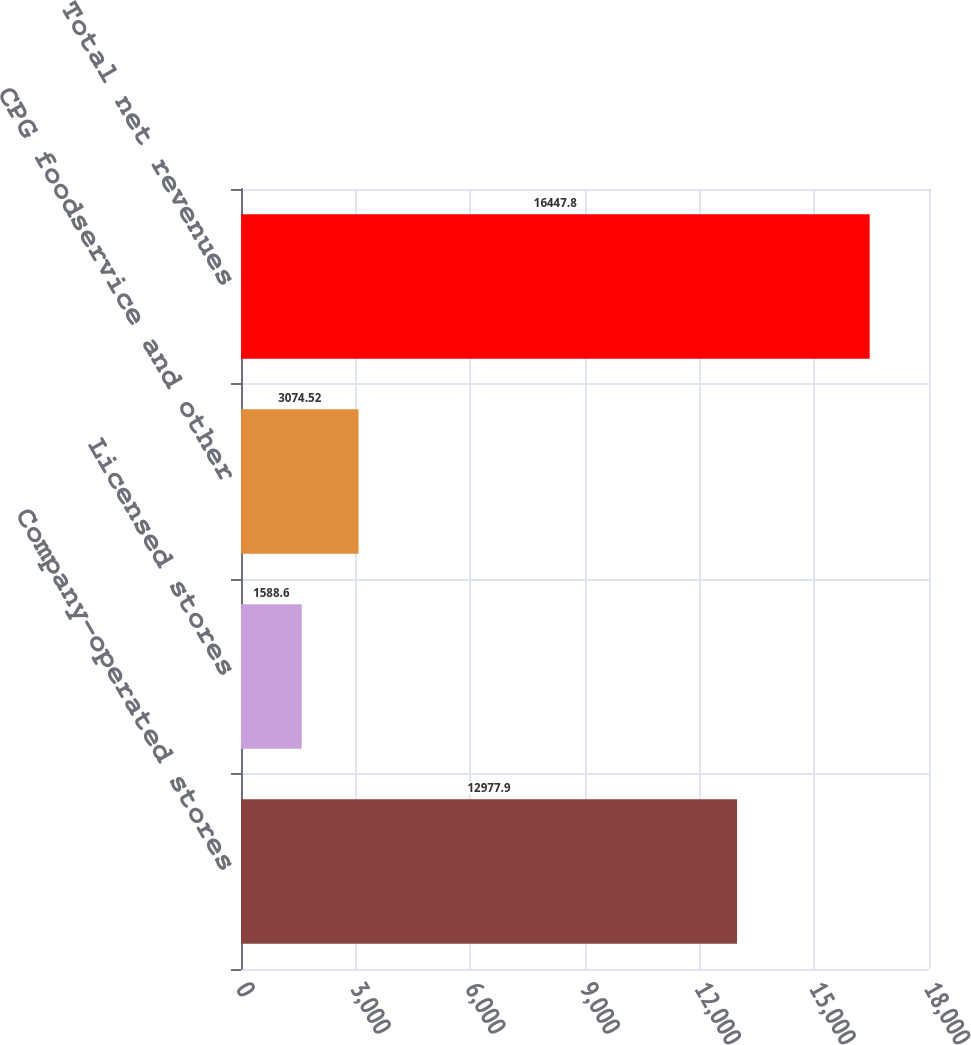Convert chart. <chart><loc_0><loc_0><loc_500><loc_500><bar_chart><fcel>Company-operated stores<fcel>Licensed stores<fcel>CPG foodservice and other<fcel>Total net revenues<nl><fcel>12977.9<fcel>1588.6<fcel>3074.52<fcel>16447.8<nl></chart> 